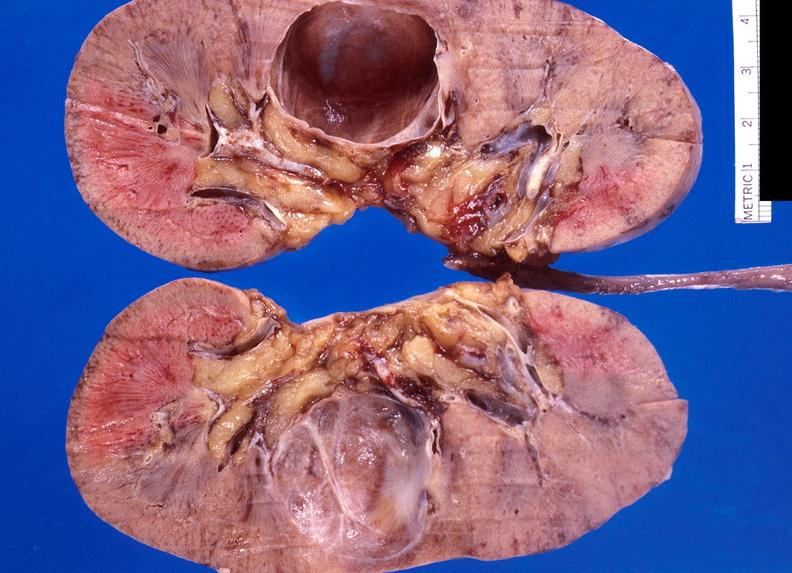where is this?
Answer the question using a single word or phrase. Urinary 